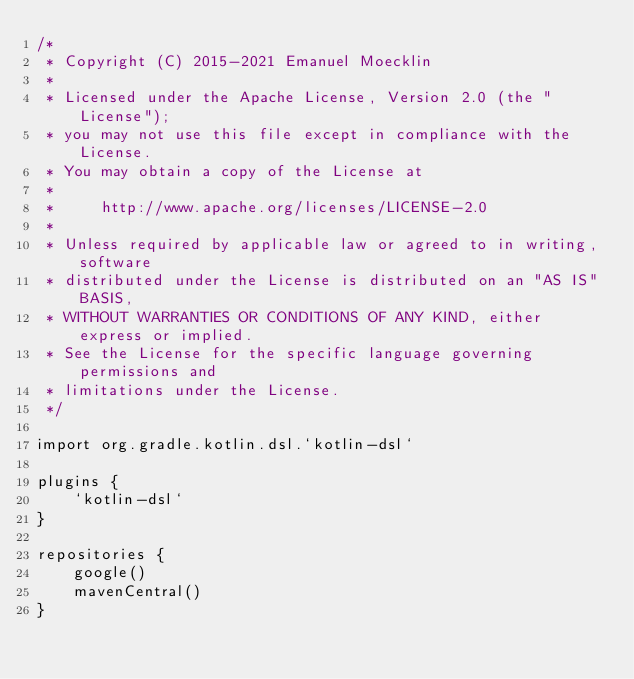Convert code to text. <code><loc_0><loc_0><loc_500><loc_500><_Kotlin_>/*
 * Copyright (C) 2015-2021 Emanuel Moecklin
 *
 * Licensed under the Apache License, Version 2.0 (the "License");
 * you may not use this file except in compliance with the License.
 * You may obtain a copy of the License at
 *
 *     http://www.apache.org/licenses/LICENSE-2.0
 *
 * Unless required by applicable law or agreed to in writing, software
 * distributed under the License is distributed on an "AS IS" BASIS,
 * WITHOUT WARRANTIES OR CONDITIONS OF ANY KIND, either express or implied.
 * See the License for the specific language governing permissions and
 * limitations under the License.
 */

import org.gradle.kotlin.dsl.`kotlin-dsl`

plugins {
    `kotlin-dsl`
}

repositories {
    google()
    mavenCentral()
}</code> 